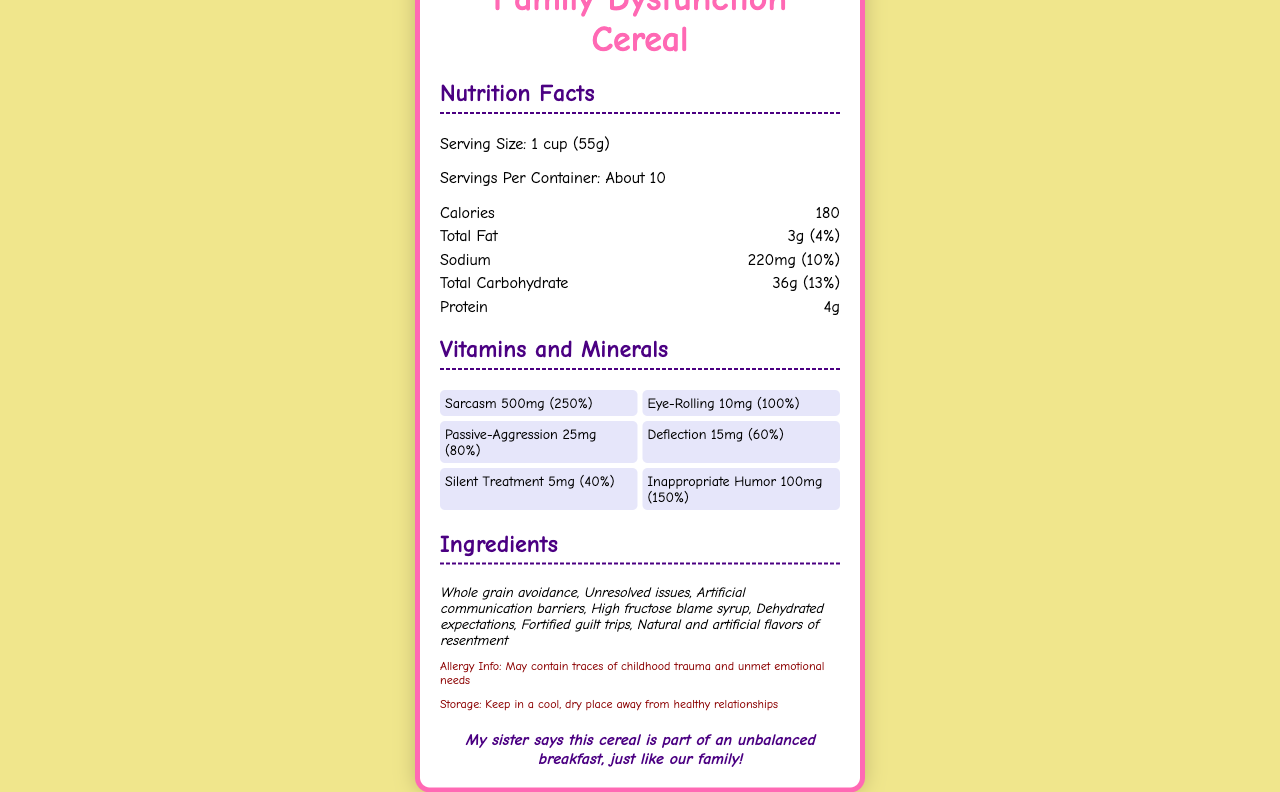what is the serving size of Family Dysfunction Cereal? The document specifies that the serving size is 1 cup, which translates to 55 grams.
Answer: 1 cup (55g) how many calories are in one serving? The calories per serving are listed as 180 in the document.
Answer: 180 what is the total amount of fat in one serving? The document states that the total fat content in one serving is 3 grams.
Answer: 3g name two ingredients in Family Dysfunction Cereal. The ingredients listed include whole grain avoidance and unresolved issues, among others.
Answer: Whole grain avoidance, Unresolved issues what percentage of the daily value of Sodium is in one serving? The sodium content in one serving is given as 220mg, which is 10% of the daily value.
Answer: 10% how much Sarcasm does one serving contain? The document states that one serving contains 500mg of Sarcasm.
Answer: 500mg what is the daily value percentage for Eye-Rolling? Eye-Rolling in one serving has a daily value percentage of 100%.
Answer: 100% which of the following is NOT an ingredient in Family Dysfunction Cereal? 
A. Natural and artificial flavors of resentment
B. Unresolved issues
C. High fructose blame syrup
D. Vitamin D The document lists ingredients like "Natural and artificial flavors of resentment," "Unresolved issues," and "High fructose blame syrup." Vitamin D is not listed as an ingredient.
Answer: D how many servings are there in one container? 
I. About 10
II. 5
III. 15
IV. 20 The document specifies that there are about 10 servings per container.
Answer: I does the cereal contain any traces of childhood trauma? The allergy information section indicates that the cereal may contain traces of childhood trauma.
Answer: Yes summarize the main idea of the document. The document primarily gives a comprehensive list of nutritional values, ingredients, and quirky vitamins and minerals of Family Dysfunction Cereal, along with comedic touches in the description and a sibling-approved joke.
Answer: The document provides nutrition facts and other details for Family Dysfunction Cereal, highlighting humorous ingredients and coping mechanisms as vitamins and minerals, sprinkled with comedic elements related to family dysfunction. who are the manufacturers of Family Dysfunction Cereal? The document lists Dysfunctional Delights, Inc. as the manufacturer.
Answer: Dysfunctional Delights, Inc. what are some vitamins and minerals listed in the cereal? The document includes a list of vitamins and minerals that contain humorous coping mechanisms such as Sarcasm, Eye-Rolling, Passive-Aggression, Deflection, Silent Treatment, and Inappropriate Humor.
Answer: Sarcasm, Eye-Rolling, Passive-Aggression, Deflection, Silent Treatment, Inappropriate Humor where should you store the cereal? The storage instructions provide this humorous advice.
Answer: Keep in a cool, dry place away from healthy relationships what is the serving size in milliliters? The document provides the serving size in grams (55g) and cups (1 cup) but does not provide information in milliliters.
Answer: Cannot be determined 